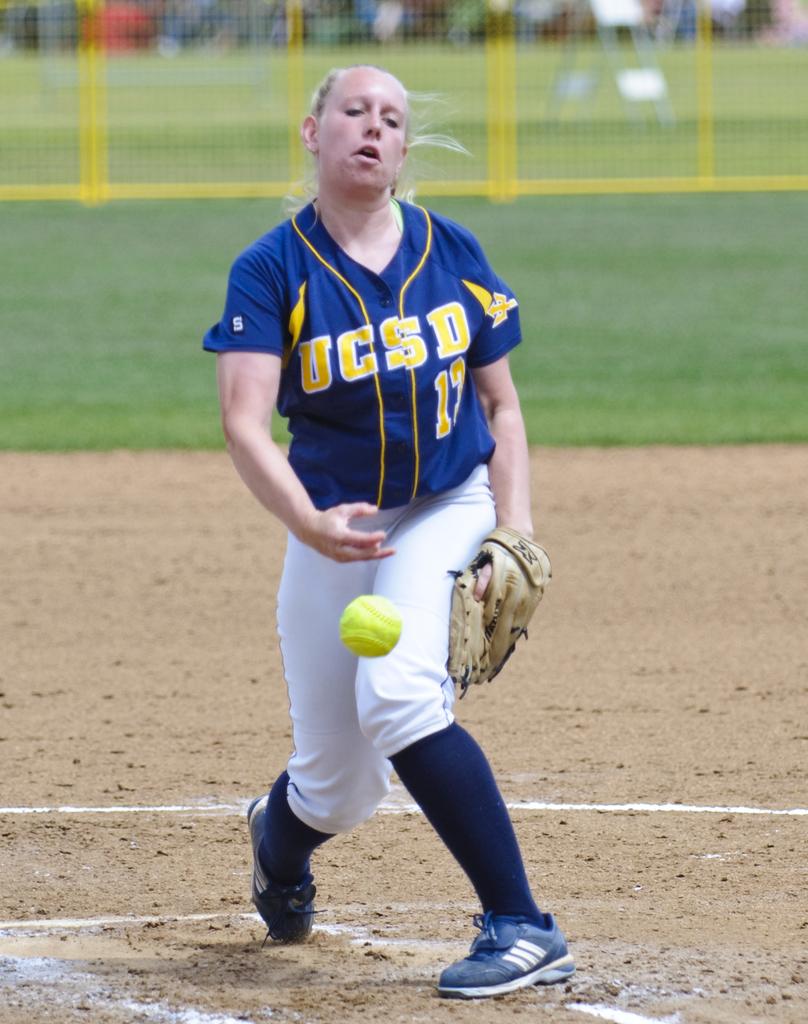What team does she play for?
Your answer should be very brief. Ucsd. How many stripes are on her trainers?
Your answer should be compact. Answering does not require reading text in the image. 